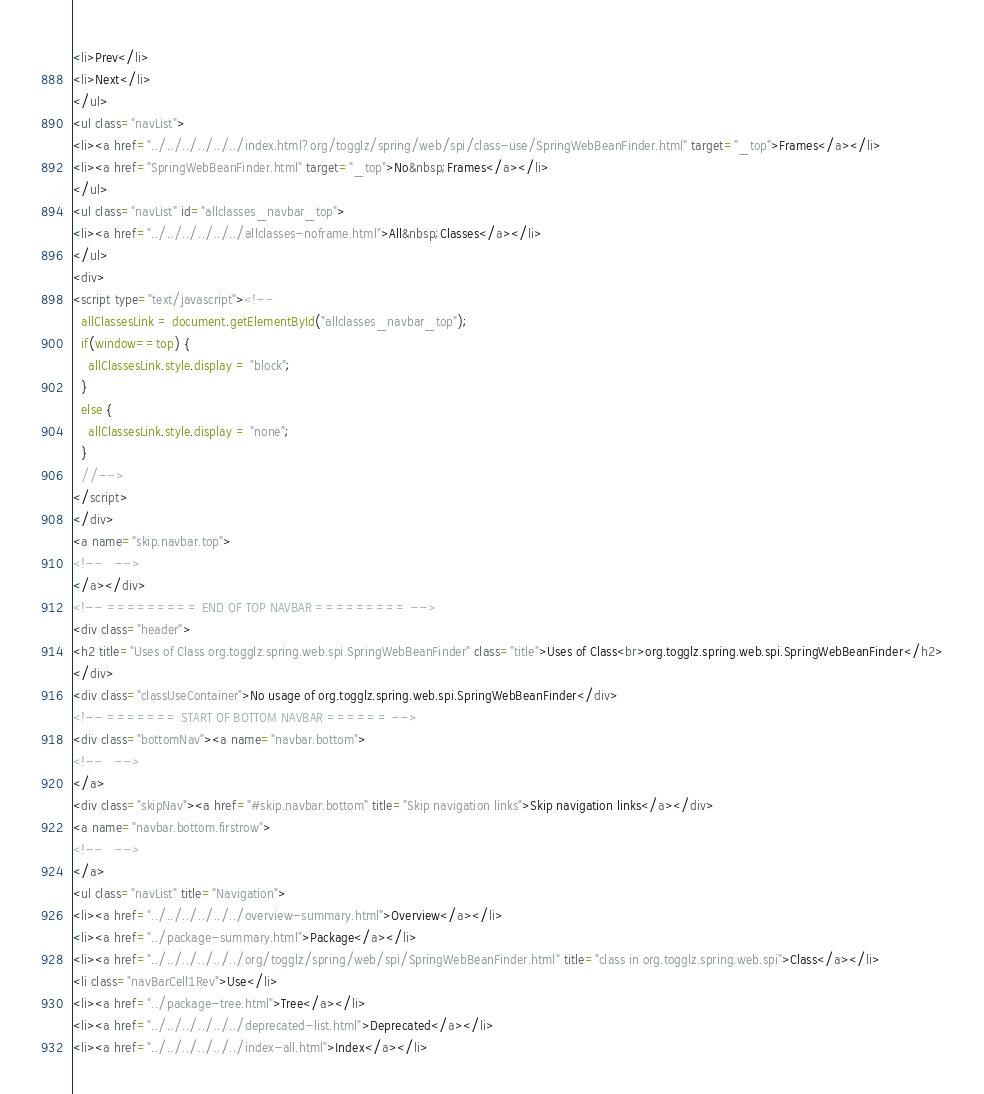<code> <loc_0><loc_0><loc_500><loc_500><_HTML_><li>Prev</li>
<li>Next</li>
</ul>
<ul class="navList">
<li><a href="../../../../../../index.html?org/togglz/spring/web/spi/class-use/SpringWebBeanFinder.html" target="_top">Frames</a></li>
<li><a href="SpringWebBeanFinder.html" target="_top">No&nbsp;Frames</a></li>
</ul>
<ul class="navList" id="allclasses_navbar_top">
<li><a href="../../../../../../allclasses-noframe.html">All&nbsp;Classes</a></li>
</ul>
<div>
<script type="text/javascript"><!--
  allClassesLink = document.getElementById("allclasses_navbar_top");
  if(window==top) {
    allClassesLink.style.display = "block";
  }
  else {
    allClassesLink.style.display = "none";
  }
  //-->
</script>
</div>
<a name="skip.navbar.top">
<!--   -->
</a></div>
<!-- ========= END OF TOP NAVBAR ========= -->
<div class="header">
<h2 title="Uses of Class org.togglz.spring.web.spi.SpringWebBeanFinder" class="title">Uses of Class<br>org.togglz.spring.web.spi.SpringWebBeanFinder</h2>
</div>
<div class="classUseContainer">No usage of org.togglz.spring.web.spi.SpringWebBeanFinder</div>
<!-- ======= START OF BOTTOM NAVBAR ====== -->
<div class="bottomNav"><a name="navbar.bottom">
<!--   -->
</a>
<div class="skipNav"><a href="#skip.navbar.bottom" title="Skip navigation links">Skip navigation links</a></div>
<a name="navbar.bottom.firstrow">
<!--   -->
</a>
<ul class="navList" title="Navigation">
<li><a href="../../../../../../overview-summary.html">Overview</a></li>
<li><a href="../package-summary.html">Package</a></li>
<li><a href="../../../../../../org/togglz/spring/web/spi/SpringWebBeanFinder.html" title="class in org.togglz.spring.web.spi">Class</a></li>
<li class="navBarCell1Rev">Use</li>
<li><a href="../package-tree.html">Tree</a></li>
<li><a href="../../../../../../deprecated-list.html">Deprecated</a></li>
<li><a href="../../../../../../index-all.html">Index</a></li></code> 